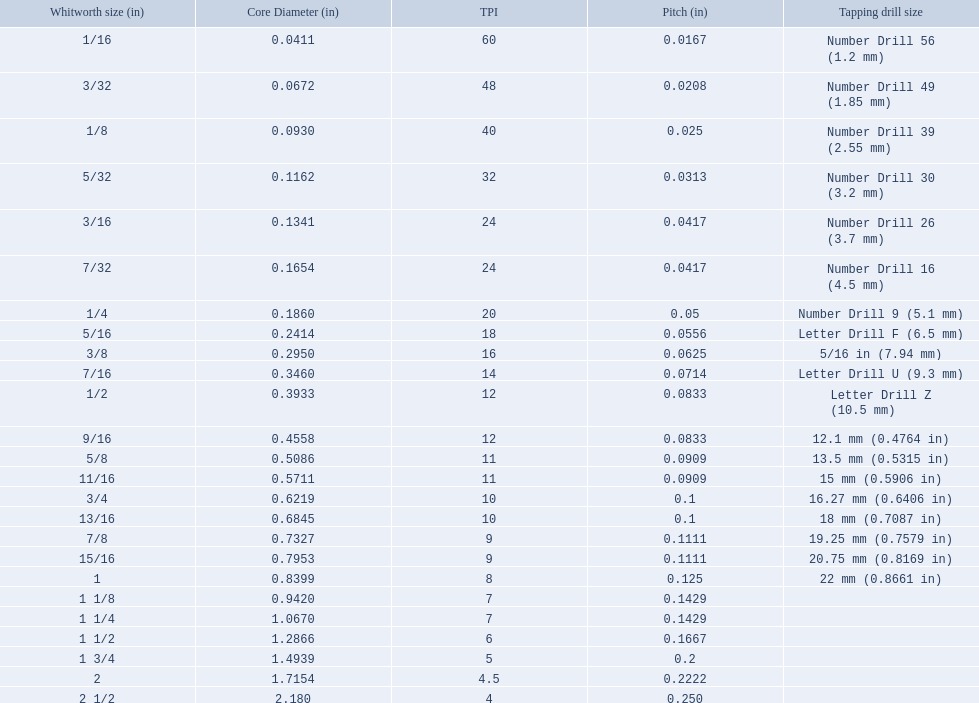What was the core diameter of a number drill 26 0.1341. What is this measurement in whitworth size? 3/16. 